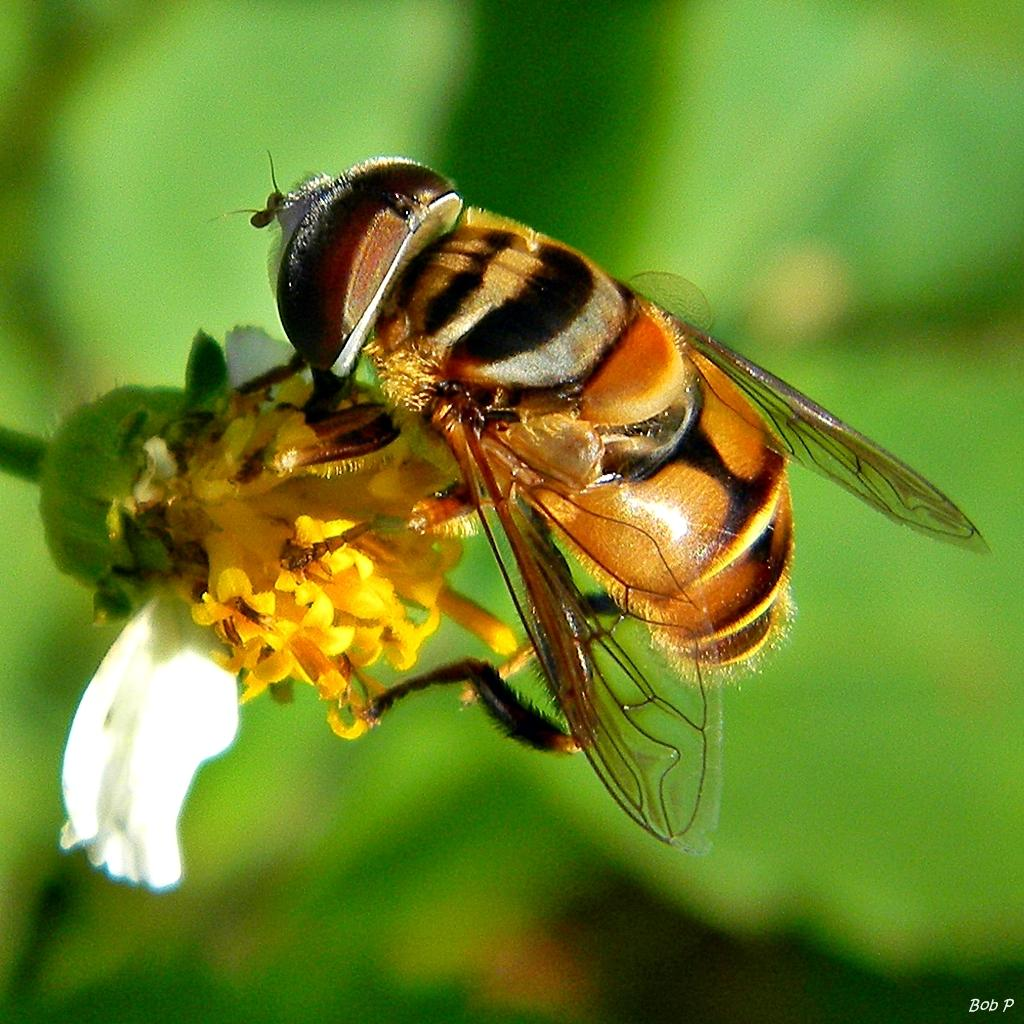What is on the flower in the image? There is an insect on the flower in the image. What else can be seen in the image besides the insect and flower? There is some text in the bottom right corner of the image. Can you describe the background of the image? The background of the image is blurry. How many cats are visible in the image? There are no cats present in the image. Is there any evidence of pollution in the image? There is no indication of pollution in the image. 